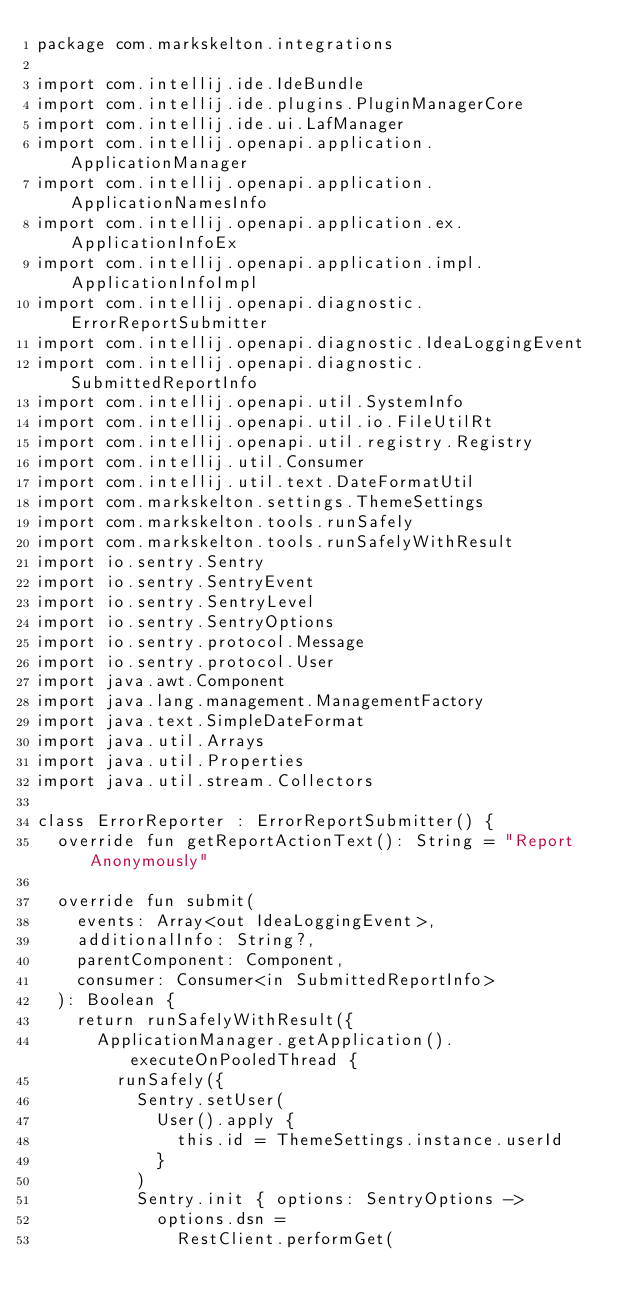Convert code to text. <code><loc_0><loc_0><loc_500><loc_500><_Kotlin_>package com.markskelton.integrations

import com.intellij.ide.IdeBundle
import com.intellij.ide.plugins.PluginManagerCore
import com.intellij.ide.ui.LafManager
import com.intellij.openapi.application.ApplicationManager
import com.intellij.openapi.application.ApplicationNamesInfo
import com.intellij.openapi.application.ex.ApplicationInfoEx
import com.intellij.openapi.application.impl.ApplicationInfoImpl
import com.intellij.openapi.diagnostic.ErrorReportSubmitter
import com.intellij.openapi.diagnostic.IdeaLoggingEvent
import com.intellij.openapi.diagnostic.SubmittedReportInfo
import com.intellij.openapi.util.SystemInfo
import com.intellij.openapi.util.io.FileUtilRt
import com.intellij.openapi.util.registry.Registry
import com.intellij.util.Consumer
import com.intellij.util.text.DateFormatUtil
import com.markskelton.settings.ThemeSettings
import com.markskelton.tools.runSafely
import com.markskelton.tools.runSafelyWithResult
import io.sentry.Sentry
import io.sentry.SentryEvent
import io.sentry.SentryLevel
import io.sentry.SentryOptions
import io.sentry.protocol.Message
import io.sentry.protocol.User
import java.awt.Component
import java.lang.management.ManagementFactory
import java.text.SimpleDateFormat
import java.util.Arrays
import java.util.Properties
import java.util.stream.Collectors

class ErrorReporter : ErrorReportSubmitter() {
  override fun getReportActionText(): String = "Report Anonymously"

  override fun submit(
    events: Array<out IdeaLoggingEvent>,
    additionalInfo: String?,
    parentComponent: Component,
    consumer: Consumer<in SubmittedReportInfo>
  ): Boolean {
    return runSafelyWithResult({
      ApplicationManager.getApplication().executeOnPooledThread {
        runSafely({
          Sentry.setUser(
            User().apply {
              this.id = ThemeSettings.instance.userId
            }
          )
          Sentry.init { options: SentryOptions ->
            options.dsn =
              RestClient.performGet(</code> 